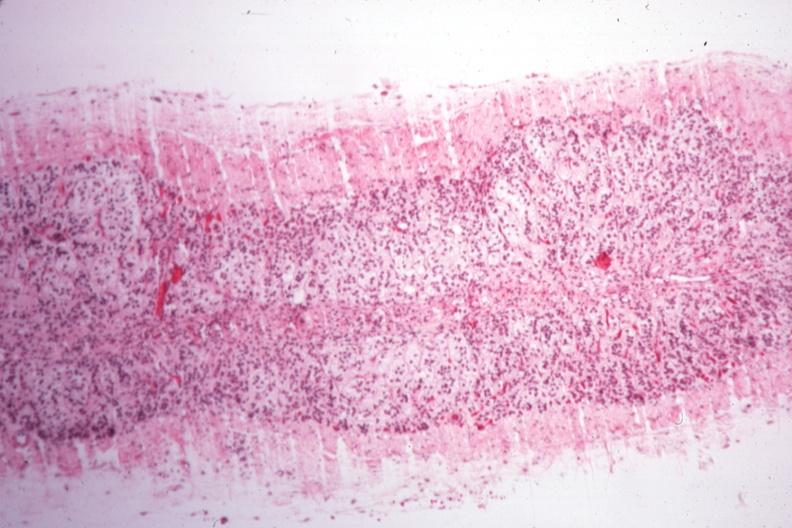s endocrine present?
Answer the question using a single word or phrase. Yes 